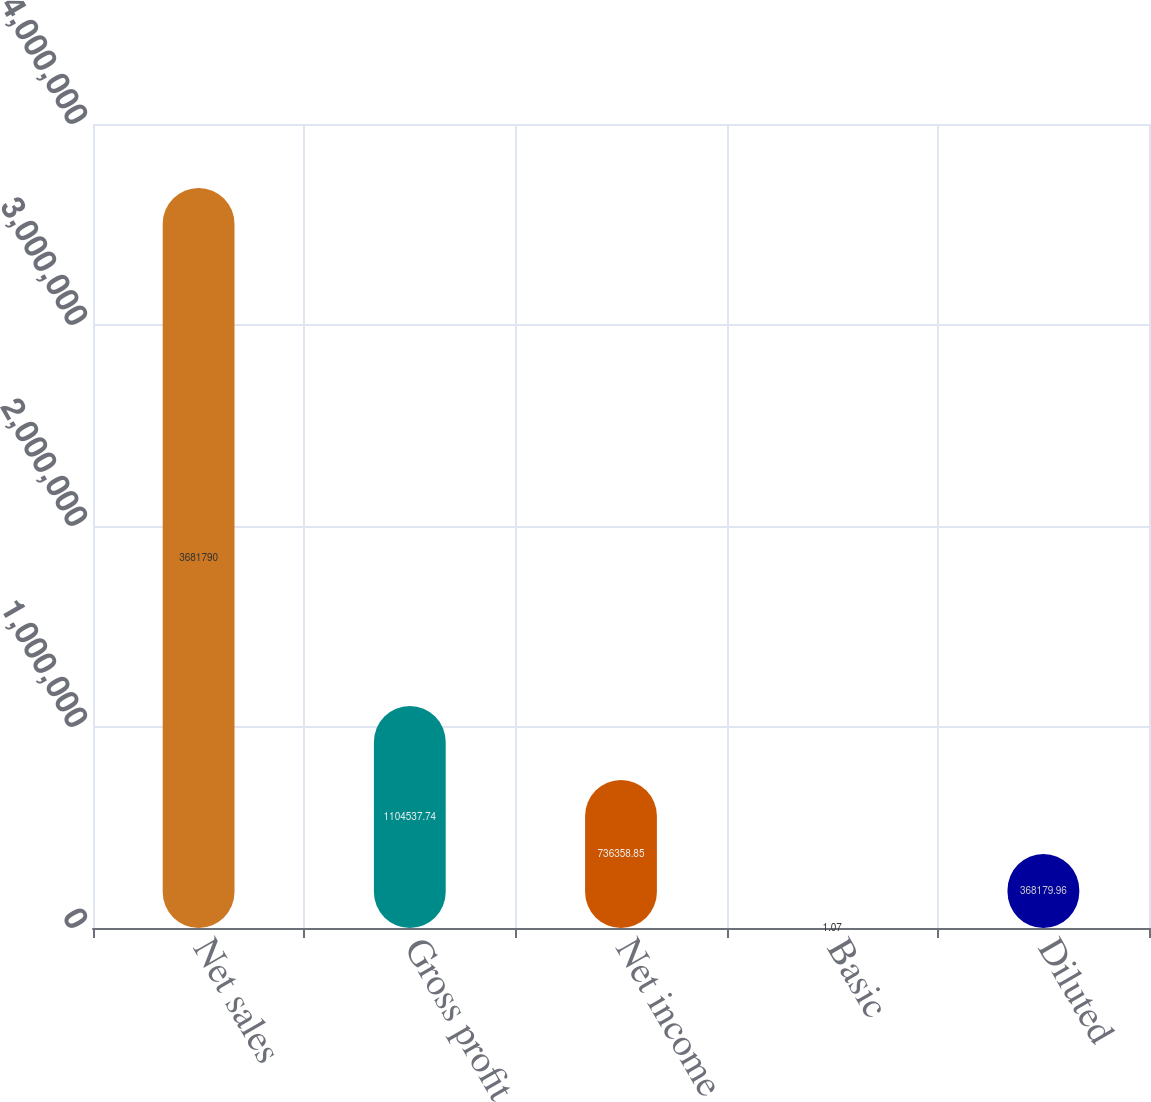<chart> <loc_0><loc_0><loc_500><loc_500><bar_chart><fcel>Net sales<fcel>Gross profit<fcel>Net income<fcel>Basic<fcel>Diluted<nl><fcel>3.68179e+06<fcel>1.10454e+06<fcel>736359<fcel>1.07<fcel>368180<nl></chart> 